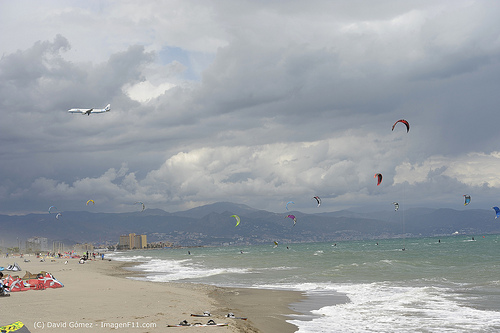Please provide the bounding box coordinate of the region this sentence describes: the sand is brown in color. The bounding box coordinates for the region described as 'the sand is brown in color' are [0.15, 0.74, 0.22, 0.79]. 